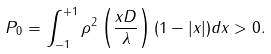Convert formula to latex. <formula><loc_0><loc_0><loc_500><loc_500>P _ { 0 } = \int _ { - 1 } ^ { + 1 } \rho ^ { 2 } \left ( \frac { x D } { \lambda } \right ) ( 1 - | x | ) d x > 0 .</formula> 